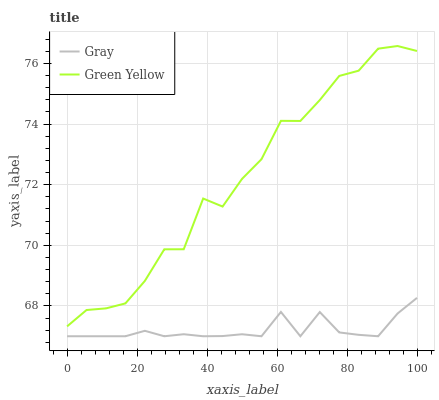Does Gray have the minimum area under the curve?
Answer yes or no. Yes. Does Green Yellow have the maximum area under the curve?
Answer yes or no. Yes. Does Green Yellow have the minimum area under the curve?
Answer yes or no. No. Is Gray the smoothest?
Answer yes or no. Yes. Is Green Yellow the roughest?
Answer yes or no. Yes. Is Green Yellow the smoothest?
Answer yes or no. No. Does Gray have the lowest value?
Answer yes or no. Yes. Does Green Yellow have the lowest value?
Answer yes or no. No. Does Green Yellow have the highest value?
Answer yes or no. Yes. Is Gray less than Green Yellow?
Answer yes or no. Yes. Is Green Yellow greater than Gray?
Answer yes or no. Yes. Does Gray intersect Green Yellow?
Answer yes or no. No. 